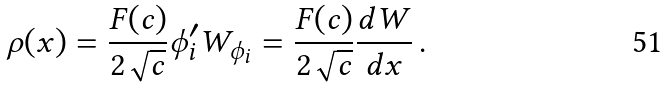Convert formula to latex. <formula><loc_0><loc_0><loc_500><loc_500>\rho ( x ) = \frac { F ( c ) } { 2 \sqrt { c } } \phi _ { i } ^ { \prime } W _ { \phi _ { i } } = \frac { F ( c ) } { 2 \sqrt { c } } \frac { d W } { d x } \, .</formula> 